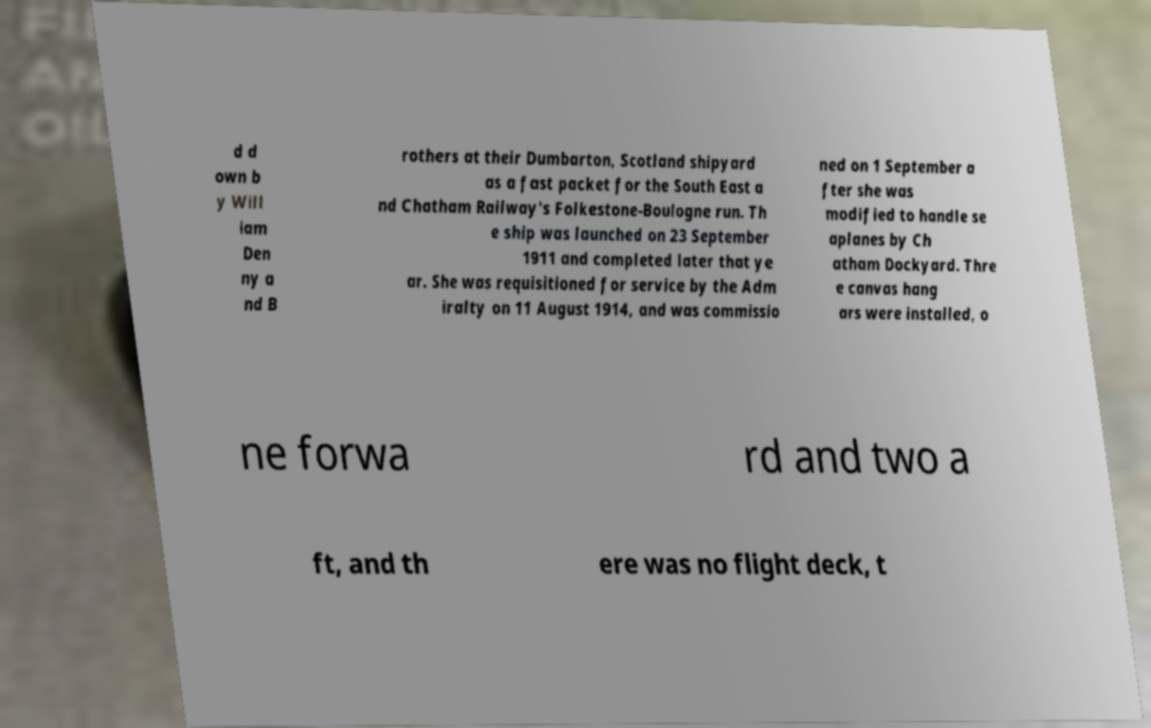There's text embedded in this image that I need extracted. Can you transcribe it verbatim? d d own b y Will iam Den ny a nd B rothers at their Dumbarton, Scotland shipyard as a fast packet for the South East a nd Chatham Railway's Folkestone-Boulogne run. Th e ship was launched on 23 September 1911 and completed later that ye ar. She was requisitioned for service by the Adm iralty on 11 August 1914, and was commissio ned on 1 September a fter she was modified to handle se aplanes by Ch atham Dockyard. Thre e canvas hang ars were installed, o ne forwa rd and two a ft, and th ere was no flight deck, t 